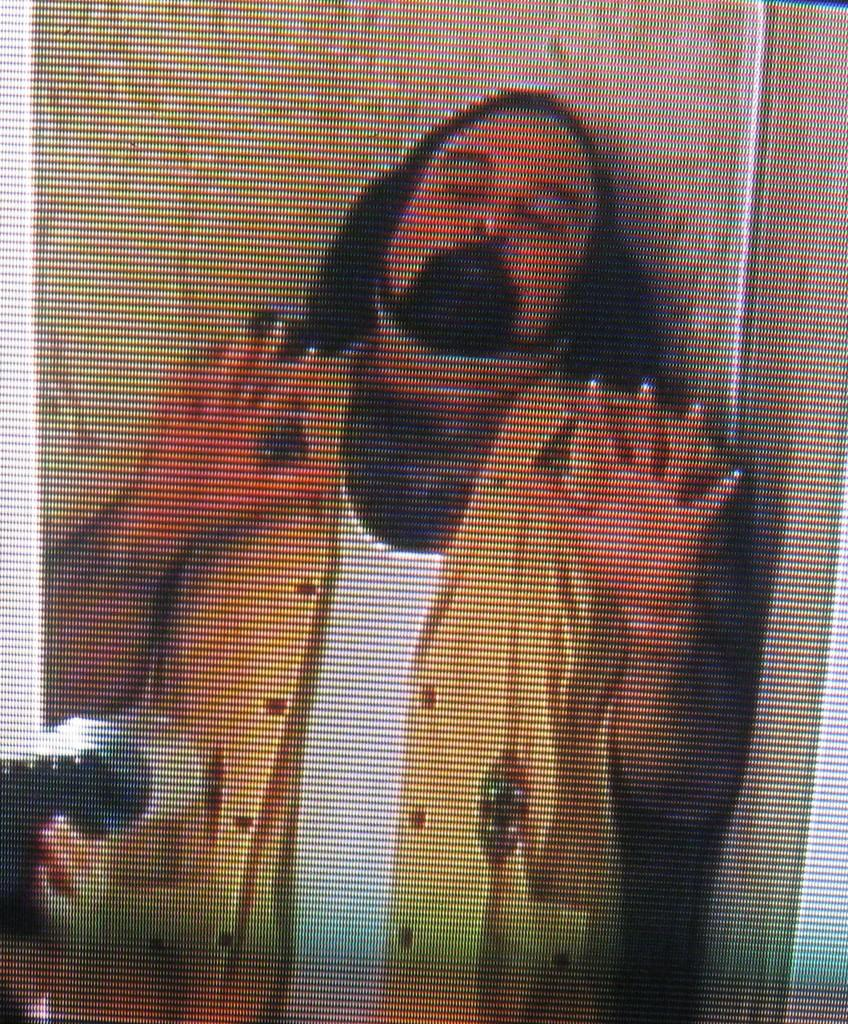What is the main subject of the image? There is a person standing in the image. What is the person wearing? The person is wearing a yellow and white color dress. What can be seen in the background of the image? There is a wall in the background of the image. What is the color of the wall? The wall is in a cream color. Can you see a robin perched on the person's shoulder in the image? No, there is no robin present in the image. What act is the person performing in the image? The image does not depict the person performing any specific act; they are simply standing. 